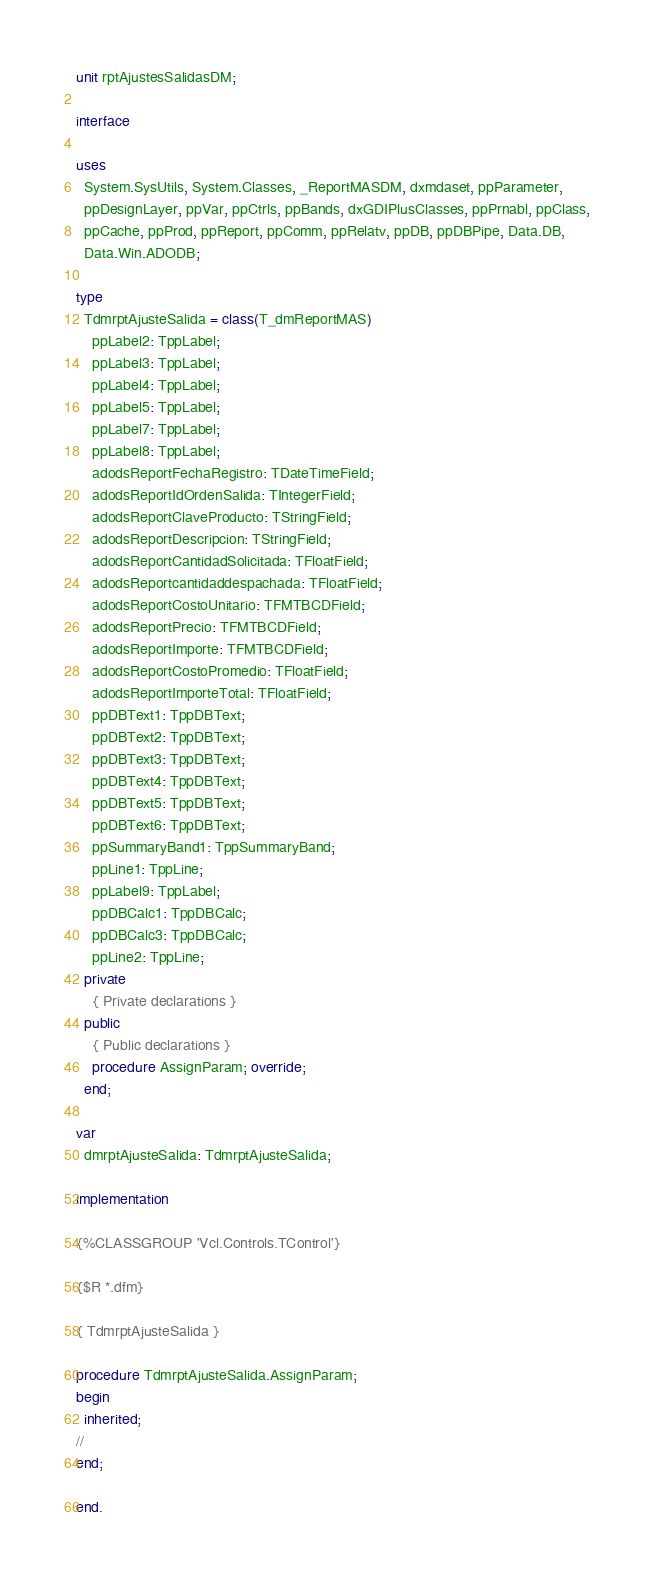Convert code to text. <code><loc_0><loc_0><loc_500><loc_500><_Pascal_>unit rptAjustesSalidasDM;

interface

uses
  System.SysUtils, System.Classes, _ReportMASDM, dxmdaset, ppParameter,
  ppDesignLayer, ppVar, ppCtrls, ppBands, dxGDIPlusClasses, ppPrnabl, ppClass,
  ppCache, ppProd, ppReport, ppComm, ppRelatv, ppDB, ppDBPipe, Data.DB,
  Data.Win.ADODB;

type
  TdmrptAjusteSalida = class(T_dmReportMAS)
    ppLabel2: TppLabel;
    ppLabel3: TppLabel;
    ppLabel4: TppLabel;
    ppLabel5: TppLabel;
    ppLabel7: TppLabel;
    ppLabel8: TppLabel;
    adodsReportFechaRegistro: TDateTimeField;
    adodsReportIdOrdenSalida: TIntegerField;
    adodsReportClaveProducto: TStringField;
    adodsReportDescripcion: TStringField;
    adodsReportCantidadSolicitada: TFloatField;
    adodsReportcantidaddespachada: TFloatField;
    adodsReportCostoUnitario: TFMTBCDField;
    adodsReportPrecio: TFMTBCDField;
    adodsReportImporte: TFMTBCDField;
    adodsReportCostoPromedio: TFloatField;
    adodsReportImporteTotal: TFloatField;
    ppDBText1: TppDBText;
    ppDBText2: TppDBText;
    ppDBText3: TppDBText;
    ppDBText4: TppDBText;
    ppDBText5: TppDBText;
    ppDBText6: TppDBText;
    ppSummaryBand1: TppSummaryBand;
    ppLine1: TppLine;
    ppLabel9: TppLabel;
    ppDBCalc1: TppDBCalc;
    ppDBCalc3: TppDBCalc;
    ppLine2: TppLine;
  private
    { Private declarations }
  public
    { Public declarations }
    procedure AssignParam; override;
  end;

var
  dmrptAjusteSalida: TdmrptAjusteSalida;

implementation

{%CLASSGROUP 'Vcl.Controls.TControl'}

{$R *.dfm}

{ TdmrptAjusteSalida }

procedure TdmrptAjusteSalida.AssignParam;
begin
  inherited;
//
end;

end.
</code> 